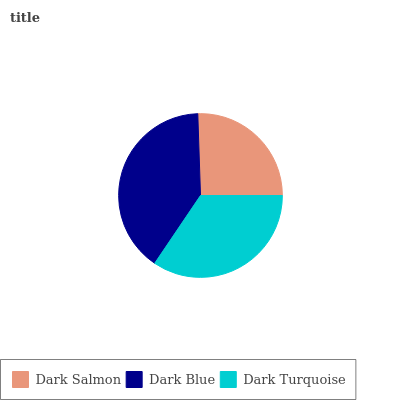Is Dark Salmon the minimum?
Answer yes or no. Yes. Is Dark Blue the maximum?
Answer yes or no. Yes. Is Dark Turquoise the minimum?
Answer yes or no. No. Is Dark Turquoise the maximum?
Answer yes or no. No. Is Dark Blue greater than Dark Turquoise?
Answer yes or no. Yes. Is Dark Turquoise less than Dark Blue?
Answer yes or no. Yes. Is Dark Turquoise greater than Dark Blue?
Answer yes or no. No. Is Dark Blue less than Dark Turquoise?
Answer yes or no. No. Is Dark Turquoise the high median?
Answer yes or no. Yes. Is Dark Turquoise the low median?
Answer yes or no. Yes. Is Dark Salmon the high median?
Answer yes or no. No. Is Dark Salmon the low median?
Answer yes or no. No. 